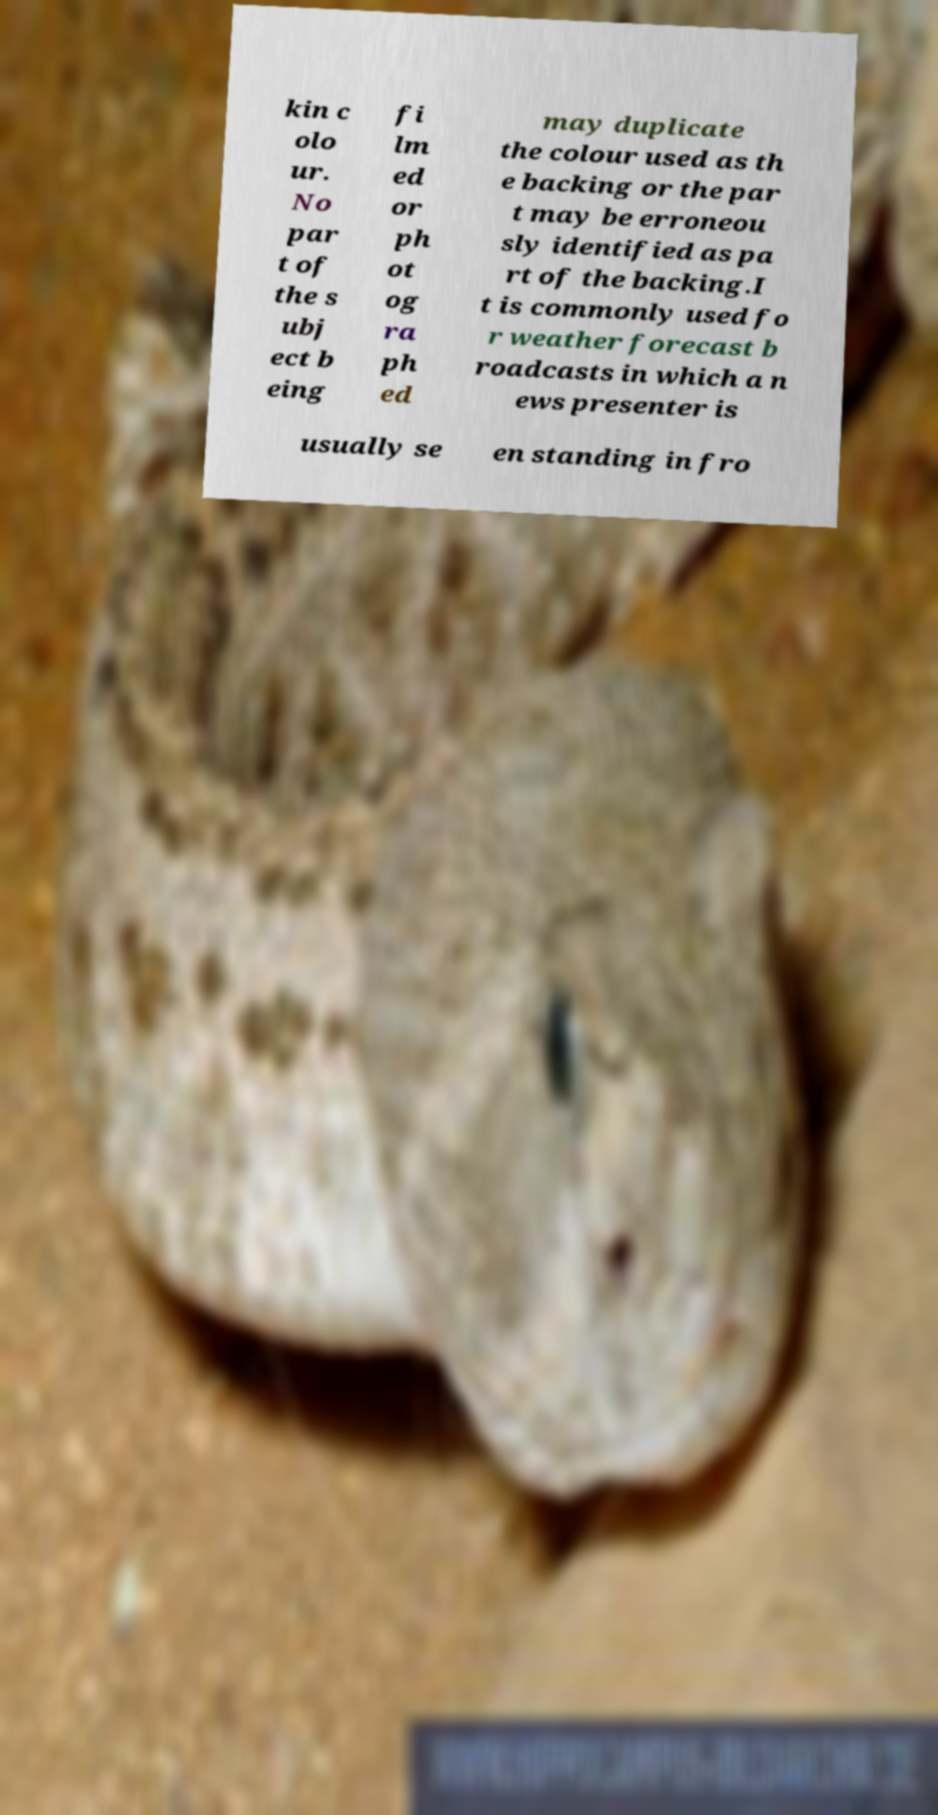Could you extract and type out the text from this image? kin c olo ur. No par t of the s ubj ect b eing fi lm ed or ph ot og ra ph ed may duplicate the colour used as th e backing or the par t may be erroneou sly identified as pa rt of the backing.I t is commonly used fo r weather forecast b roadcasts in which a n ews presenter is usually se en standing in fro 